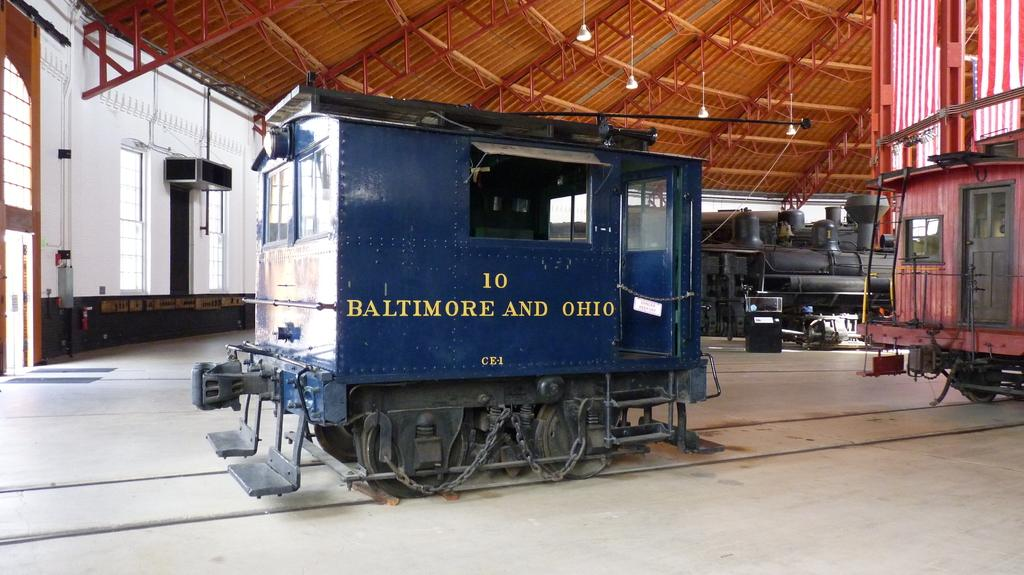What type of vehicles are in the image? There are train compartments in the image. Where are the train compartments located? The train compartments are on a track. What can be seen on the ceiling of the train compartments? There are lights on the ceiling in the image. What type of building is shown in the image? The image appears to show a warehouse. Is there any text visible in the image? Yes, there is text visible on the train compartment. What advice does the family in the image give to the receipt? There is no family or receipt present in the image; it features train compartments in a warehouse setting. 